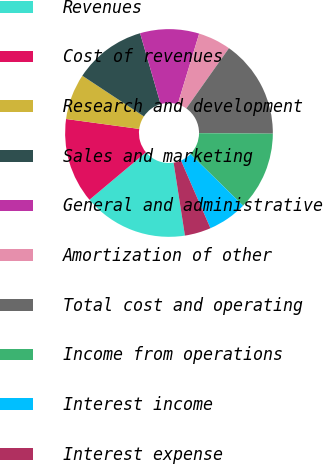<chart> <loc_0><loc_0><loc_500><loc_500><pie_chart><fcel>Revenues<fcel>Cost of revenues<fcel>Research and development<fcel>Sales and marketing<fcel>General and administrative<fcel>Amortization of other<fcel>Total cost and operating<fcel>Income from operations<fcel>Interest income<fcel>Interest expense<nl><fcel>16.33%<fcel>13.27%<fcel>7.14%<fcel>11.22%<fcel>9.18%<fcel>5.1%<fcel>15.31%<fcel>12.24%<fcel>6.12%<fcel>4.08%<nl></chart> 